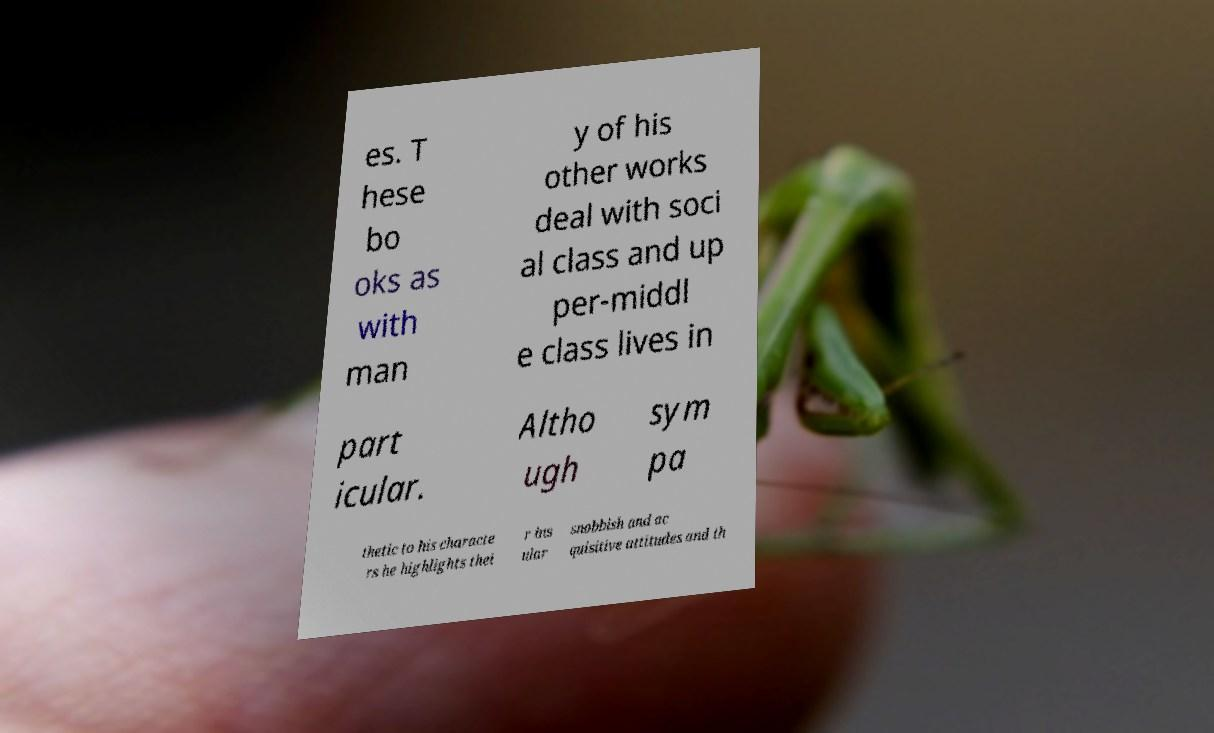Please read and relay the text visible in this image. What does it say? es. T hese bo oks as with man y of his other works deal with soci al class and up per-middl e class lives in part icular. Altho ugh sym pa thetic to his characte rs he highlights thei r ins ular snobbish and ac quisitive attitudes and th 